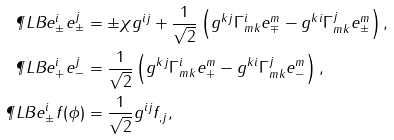Convert formula to latex. <formula><loc_0><loc_0><loc_500><loc_500>\P L B { e ^ { i } _ { \pm } } { e ^ { j } _ { \pm } } & = \pm \chi g ^ { i j } + \frac { 1 } { \sqrt { 2 } } \left ( g ^ { k j } \Gamma ^ { i } _ { m k } e _ { \mp } ^ { m } - g ^ { k i } \Gamma ^ { j } _ { m k } e _ { \pm } ^ { m } \right ) , \\ \P L B { e ^ { i } _ { + } } { e ^ { j } _ { - } } & = \frac { 1 } { \sqrt { 2 } } \left ( g ^ { k j } \Gamma ^ { i } _ { m k } e _ { + } ^ { m } - g ^ { k i } \Gamma ^ { j } _ { m k } e _ { - } ^ { m } \right ) , \\ \P L B { e ^ { i } _ { \pm } } { f ( \phi ) } & = \frac { 1 } { \sqrt { 2 } } g ^ { i j } f _ { , j } ,</formula> 